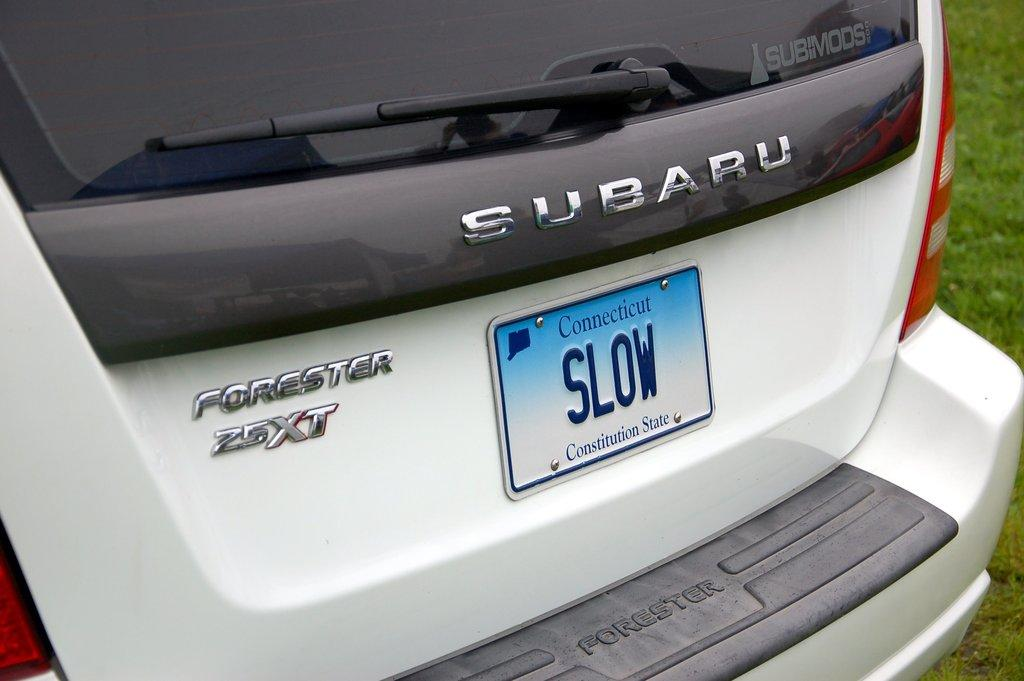<image>
Describe the image concisely. White van with a license plate which says SLOW. 